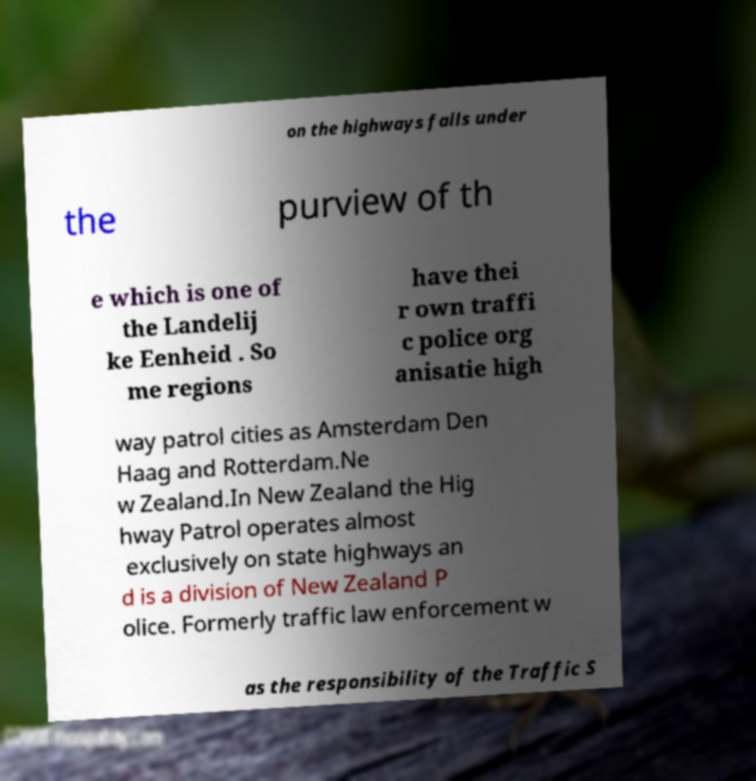Can you read and provide the text displayed in the image?This photo seems to have some interesting text. Can you extract and type it out for me? on the highways falls under the purview of th e which is one of the Landelij ke Eenheid . So me regions have thei r own traffi c police org anisatie high way patrol cities as Amsterdam Den Haag and Rotterdam.Ne w Zealand.In New Zealand the Hig hway Patrol operates almost exclusively on state highways an d is a division of New Zealand P olice. Formerly traffic law enforcement w as the responsibility of the Traffic S 